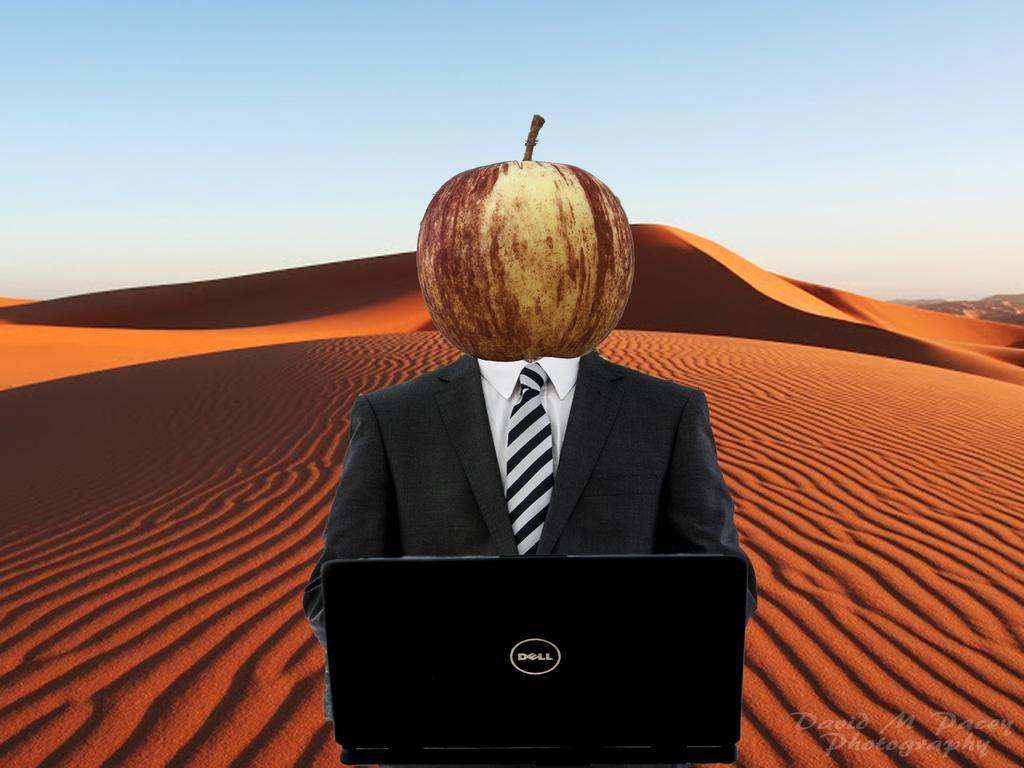Could you give a brief overview of what you see in this image? In this image, we can see person who´s face is not visible and instead of that we can see an apple. There is a laptop in the middle of the image. There is a desert in the middle of the image. There is a sky at the top of the image. 